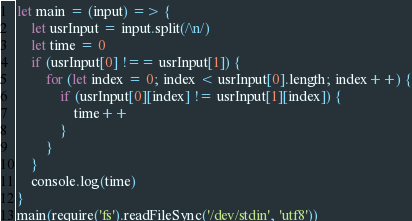Convert code to text. <code><loc_0><loc_0><loc_500><loc_500><_JavaScript_>let main = (input) => {
    let usrInput = input.split(/\n/)
    let time = 0
    if (usrInput[0] !== usrInput[1]) {
        for (let index = 0; index < usrInput[0].length; index++) {
            if (usrInput[0][index] != usrInput[1][index]) {
                time++
            }
        }
    }
    console.log(time)
}
main(require('fs').readFileSync('/dev/stdin', 'utf8'))</code> 